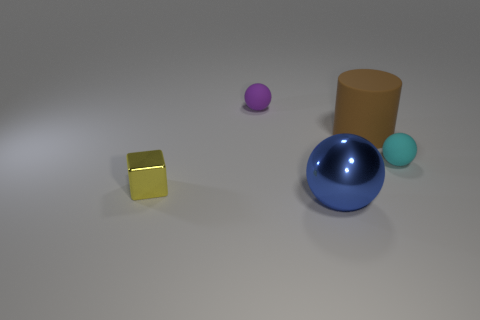What objects are present in the image and what colors are they? The image shows four objects on a flat surface. From left to right, there's a shiny yellow cube, a small purple ball, a large reflective blue ball, and a matte brown cylinder besides a smaller, sky blue ball. 